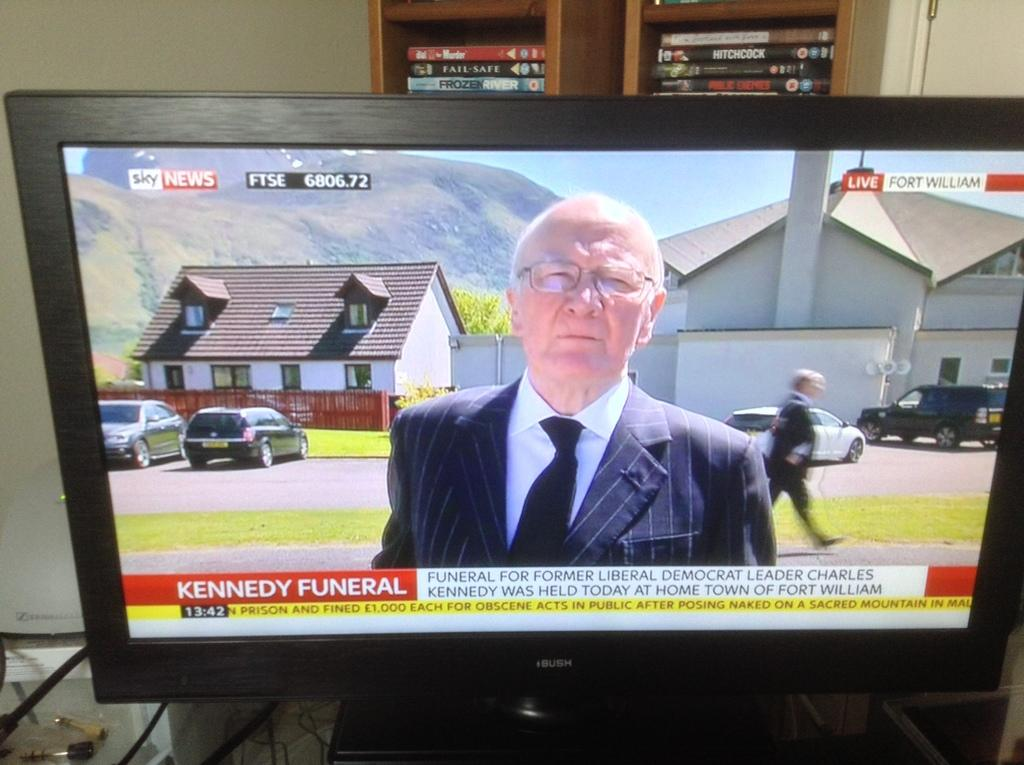Provide a one-sentence caption for the provided image. A television shows the Kennedy Funeral on a news program. 